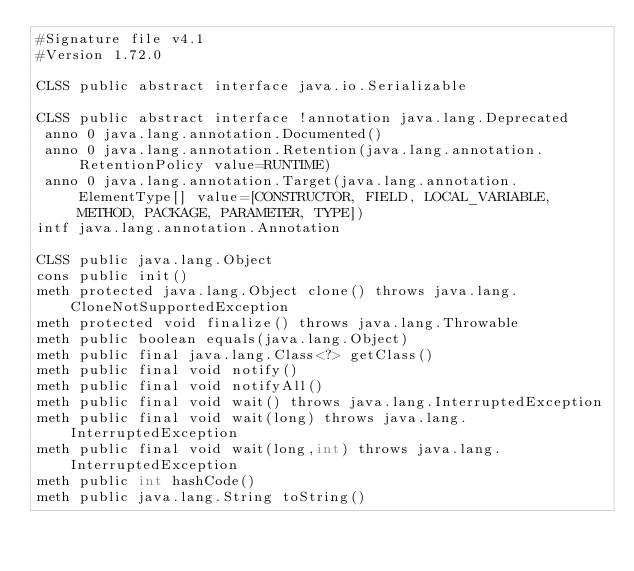<code> <loc_0><loc_0><loc_500><loc_500><_SML_>#Signature file v4.1
#Version 1.72.0

CLSS public abstract interface java.io.Serializable

CLSS public abstract interface !annotation java.lang.Deprecated
 anno 0 java.lang.annotation.Documented()
 anno 0 java.lang.annotation.Retention(java.lang.annotation.RetentionPolicy value=RUNTIME)
 anno 0 java.lang.annotation.Target(java.lang.annotation.ElementType[] value=[CONSTRUCTOR, FIELD, LOCAL_VARIABLE, METHOD, PACKAGE, PARAMETER, TYPE])
intf java.lang.annotation.Annotation

CLSS public java.lang.Object
cons public init()
meth protected java.lang.Object clone() throws java.lang.CloneNotSupportedException
meth protected void finalize() throws java.lang.Throwable
meth public boolean equals(java.lang.Object)
meth public final java.lang.Class<?> getClass()
meth public final void notify()
meth public final void notifyAll()
meth public final void wait() throws java.lang.InterruptedException
meth public final void wait(long) throws java.lang.InterruptedException
meth public final void wait(long,int) throws java.lang.InterruptedException
meth public int hashCode()
meth public java.lang.String toString()
</code> 